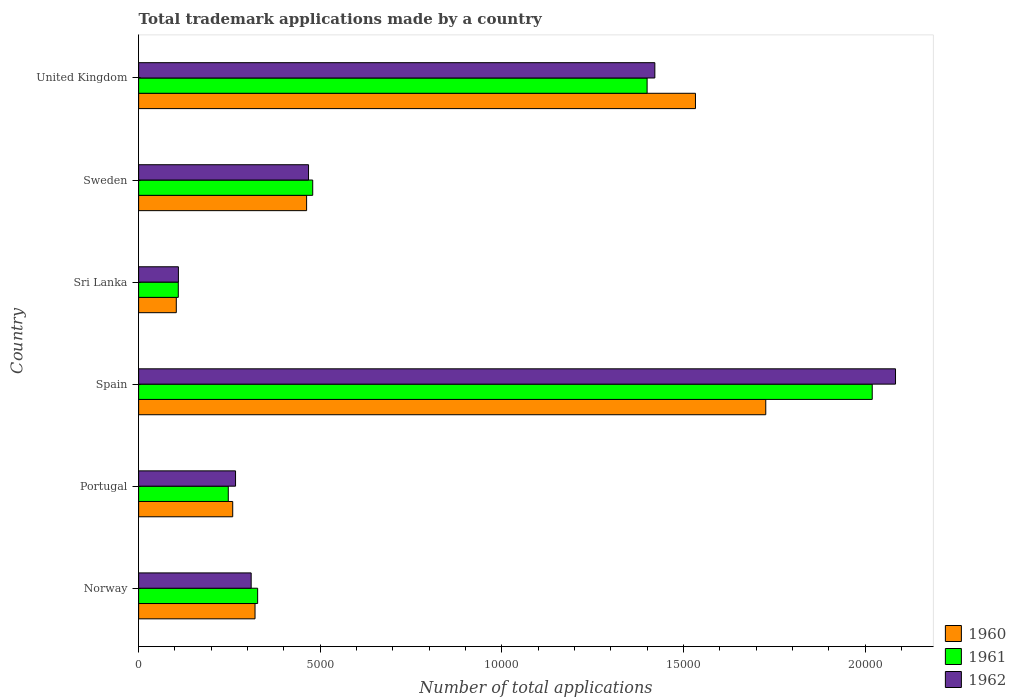How many different coloured bars are there?
Provide a short and direct response. 3. How many groups of bars are there?
Provide a succinct answer. 6. Are the number of bars per tick equal to the number of legend labels?
Your answer should be compact. Yes. How many bars are there on the 4th tick from the bottom?
Your answer should be compact. 3. What is the number of applications made by in 1961 in Sweden?
Your answer should be compact. 4792. Across all countries, what is the maximum number of applications made by in 1962?
Provide a succinct answer. 2.08e+04. Across all countries, what is the minimum number of applications made by in 1961?
Your answer should be very brief. 1092. In which country was the number of applications made by in 1961 minimum?
Your answer should be compact. Sri Lanka. What is the total number of applications made by in 1961 in the graph?
Make the answer very short. 4.58e+04. What is the difference between the number of applications made by in 1962 in Sweden and that in United Kingdom?
Provide a succinct answer. -9533. What is the difference between the number of applications made by in 1961 in United Kingdom and the number of applications made by in 1960 in Portugal?
Offer a terse response. 1.14e+04. What is the average number of applications made by in 1962 per country?
Make the answer very short. 7763.83. What is the difference between the number of applications made by in 1961 and number of applications made by in 1962 in Sri Lanka?
Your answer should be very brief. -3. What is the ratio of the number of applications made by in 1962 in Portugal to that in Sweden?
Your answer should be very brief. 0.57. Is the number of applications made by in 1961 in Norway less than that in Spain?
Ensure brevity in your answer.  Yes. Is the difference between the number of applications made by in 1961 in Portugal and United Kingdom greater than the difference between the number of applications made by in 1962 in Portugal and United Kingdom?
Provide a succinct answer. Yes. What is the difference between the highest and the second highest number of applications made by in 1960?
Give a very brief answer. 1935. What is the difference between the highest and the lowest number of applications made by in 1962?
Provide a short and direct response. 1.97e+04. In how many countries, is the number of applications made by in 1961 greater than the average number of applications made by in 1961 taken over all countries?
Ensure brevity in your answer.  2. Is the sum of the number of applications made by in 1960 in Portugal and Sri Lanka greater than the maximum number of applications made by in 1962 across all countries?
Offer a terse response. No. Is it the case that in every country, the sum of the number of applications made by in 1961 and number of applications made by in 1960 is greater than the number of applications made by in 1962?
Offer a terse response. Yes. Are all the bars in the graph horizontal?
Offer a terse response. Yes. Are the values on the major ticks of X-axis written in scientific E-notation?
Provide a succinct answer. No. Does the graph contain any zero values?
Provide a short and direct response. No. Does the graph contain grids?
Your response must be concise. No. How many legend labels are there?
Ensure brevity in your answer.  3. How are the legend labels stacked?
Ensure brevity in your answer.  Vertical. What is the title of the graph?
Keep it short and to the point. Total trademark applications made by a country. Does "1988" appear as one of the legend labels in the graph?
Provide a short and direct response. No. What is the label or title of the X-axis?
Provide a short and direct response. Number of total applications. What is the label or title of the Y-axis?
Provide a succinct answer. Country. What is the Number of total applications in 1960 in Norway?
Give a very brief answer. 3204. What is the Number of total applications of 1961 in Norway?
Your answer should be very brief. 3276. What is the Number of total applications in 1962 in Norway?
Your response must be concise. 3098. What is the Number of total applications in 1960 in Portugal?
Make the answer very short. 2590. What is the Number of total applications of 1961 in Portugal?
Offer a terse response. 2468. What is the Number of total applications in 1962 in Portugal?
Your response must be concise. 2668. What is the Number of total applications in 1960 in Spain?
Provide a short and direct response. 1.73e+04. What is the Number of total applications in 1961 in Spain?
Provide a short and direct response. 2.02e+04. What is the Number of total applications of 1962 in Spain?
Give a very brief answer. 2.08e+04. What is the Number of total applications of 1960 in Sri Lanka?
Keep it short and to the point. 1037. What is the Number of total applications in 1961 in Sri Lanka?
Offer a terse response. 1092. What is the Number of total applications of 1962 in Sri Lanka?
Your response must be concise. 1095. What is the Number of total applications of 1960 in Sweden?
Your response must be concise. 4624. What is the Number of total applications in 1961 in Sweden?
Offer a very short reply. 4792. What is the Number of total applications in 1962 in Sweden?
Your response must be concise. 4677. What is the Number of total applications in 1960 in United Kingdom?
Ensure brevity in your answer.  1.53e+04. What is the Number of total applications of 1961 in United Kingdom?
Provide a succinct answer. 1.40e+04. What is the Number of total applications of 1962 in United Kingdom?
Offer a very short reply. 1.42e+04. Across all countries, what is the maximum Number of total applications of 1960?
Keep it short and to the point. 1.73e+04. Across all countries, what is the maximum Number of total applications in 1961?
Make the answer very short. 2.02e+04. Across all countries, what is the maximum Number of total applications of 1962?
Give a very brief answer. 2.08e+04. Across all countries, what is the minimum Number of total applications of 1960?
Your answer should be very brief. 1037. Across all countries, what is the minimum Number of total applications in 1961?
Give a very brief answer. 1092. Across all countries, what is the minimum Number of total applications in 1962?
Your response must be concise. 1095. What is the total Number of total applications in 1960 in the graph?
Give a very brief answer. 4.40e+04. What is the total Number of total applications of 1961 in the graph?
Provide a short and direct response. 4.58e+04. What is the total Number of total applications of 1962 in the graph?
Make the answer very short. 4.66e+04. What is the difference between the Number of total applications in 1960 in Norway and that in Portugal?
Keep it short and to the point. 614. What is the difference between the Number of total applications of 1961 in Norway and that in Portugal?
Offer a terse response. 808. What is the difference between the Number of total applications in 1962 in Norway and that in Portugal?
Your answer should be compact. 430. What is the difference between the Number of total applications in 1960 in Norway and that in Spain?
Make the answer very short. -1.41e+04. What is the difference between the Number of total applications in 1961 in Norway and that in Spain?
Make the answer very short. -1.69e+04. What is the difference between the Number of total applications in 1962 in Norway and that in Spain?
Your answer should be compact. -1.77e+04. What is the difference between the Number of total applications of 1960 in Norway and that in Sri Lanka?
Ensure brevity in your answer.  2167. What is the difference between the Number of total applications of 1961 in Norway and that in Sri Lanka?
Offer a terse response. 2184. What is the difference between the Number of total applications of 1962 in Norway and that in Sri Lanka?
Offer a very short reply. 2003. What is the difference between the Number of total applications of 1960 in Norway and that in Sweden?
Provide a short and direct response. -1420. What is the difference between the Number of total applications in 1961 in Norway and that in Sweden?
Keep it short and to the point. -1516. What is the difference between the Number of total applications of 1962 in Norway and that in Sweden?
Give a very brief answer. -1579. What is the difference between the Number of total applications in 1960 in Norway and that in United Kingdom?
Offer a very short reply. -1.21e+04. What is the difference between the Number of total applications of 1961 in Norway and that in United Kingdom?
Give a very brief answer. -1.07e+04. What is the difference between the Number of total applications in 1962 in Norway and that in United Kingdom?
Your answer should be compact. -1.11e+04. What is the difference between the Number of total applications in 1960 in Portugal and that in Spain?
Keep it short and to the point. -1.47e+04. What is the difference between the Number of total applications of 1961 in Portugal and that in Spain?
Provide a short and direct response. -1.77e+04. What is the difference between the Number of total applications in 1962 in Portugal and that in Spain?
Make the answer very short. -1.82e+04. What is the difference between the Number of total applications of 1960 in Portugal and that in Sri Lanka?
Offer a very short reply. 1553. What is the difference between the Number of total applications of 1961 in Portugal and that in Sri Lanka?
Offer a terse response. 1376. What is the difference between the Number of total applications of 1962 in Portugal and that in Sri Lanka?
Give a very brief answer. 1573. What is the difference between the Number of total applications in 1960 in Portugal and that in Sweden?
Your answer should be compact. -2034. What is the difference between the Number of total applications in 1961 in Portugal and that in Sweden?
Make the answer very short. -2324. What is the difference between the Number of total applications in 1962 in Portugal and that in Sweden?
Your answer should be very brief. -2009. What is the difference between the Number of total applications of 1960 in Portugal and that in United Kingdom?
Your response must be concise. -1.27e+04. What is the difference between the Number of total applications of 1961 in Portugal and that in United Kingdom?
Your answer should be compact. -1.15e+04. What is the difference between the Number of total applications of 1962 in Portugal and that in United Kingdom?
Make the answer very short. -1.15e+04. What is the difference between the Number of total applications of 1960 in Spain and that in Sri Lanka?
Provide a short and direct response. 1.62e+04. What is the difference between the Number of total applications in 1961 in Spain and that in Sri Lanka?
Your response must be concise. 1.91e+04. What is the difference between the Number of total applications in 1962 in Spain and that in Sri Lanka?
Offer a terse response. 1.97e+04. What is the difference between the Number of total applications of 1960 in Spain and that in Sweden?
Provide a succinct answer. 1.26e+04. What is the difference between the Number of total applications in 1961 in Spain and that in Sweden?
Keep it short and to the point. 1.54e+04. What is the difference between the Number of total applications in 1962 in Spain and that in Sweden?
Your response must be concise. 1.62e+04. What is the difference between the Number of total applications in 1960 in Spain and that in United Kingdom?
Make the answer very short. 1935. What is the difference between the Number of total applications of 1961 in Spain and that in United Kingdom?
Keep it short and to the point. 6197. What is the difference between the Number of total applications of 1962 in Spain and that in United Kingdom?
Offer a very short reply. 6625. What is the difference between the Number of total applications of 1960 in Sri Lanka and that in Sweden?
Ensure brevity in your answer.  -3587. What is the difference between the Number of total applications in 1961 in Sri Lanka and that in Sweden?
Offer a very short reply. -3700. What is the difference between the Number of total applications in 1962 in Sri Lanka and that in Sweden?
Provide a succinct answer. -3582. What is the difference between the Number of total applications in 1960 in Sri Lanka and that in United Kingdom?
Make the answer very short. -1.43e+04. What is the difference between the Number of total applications in 1961 in Sri Lanka and that in United Kingdom?
Keep it short and to the point. -1.29e+04. What is the difference between the Number of total applications in 1962 in Sri Lanka and that in United Kingdom?
Ensure brevity in your answer.  -1.31e+04. What is the difference between the Number of total applications in 1960 in Sweden and that in United Kingdom?
Provide a succinct answer. -1.07e+04. What is the difference between the Number of total applications of 1961 in Sweden and that in United Kingdom?
Ensure brevity in your answer.  -9205. What is the difference between the Number of total applications in 1962 in Sweden and that in United Kingdom?
Keep it short and to the point. -9533. What is the difference between the Number of total applications of 1960 in Norway and the Number of total applications of 1961 in Portugal?
Give a very brief answer. 736. What is the difference between the Number of total applications in 1960 in Norway and the Number of total applications in 1962 in Portugal?
Provide a succinct answer. 536. What is the difference between the Number of total applications in 1961 in Norway and the Number of total applications in 1962 in Portugal?
Keep it short and to the point. 608. What is the difference between the Number of total applications in 1960 in Norway and the Number of total applications in 1961 in Spain?
Ensure brevity in your answer.  -1.70e+04. What is the difference between the Number of total applications in 1960 in Norway and the Number of total applications in 1962 in Spain?
Give a very brief answer. -1.76e+04. What is the difference between the Number of total applications in 1961 in Norway and the Number of total applications in 1962 in Spain?
Offer a very short reply. -1.76e+04. What is the difference between the Number of total applications of 1960 in Norway and the Number of total applications of 1961 in Sri Lanka?
Provide a short and direct response. 2112. What is the difference between the Number of total applications in 1960 in Norway and the Number of total applications in 1962 in Sri Lanka?
Give a very brief answer. 2109. What is the difference between the Number of total applications in 1961 in Norway and the Number of total applications in 1962 in Sri Lanka?
Make the answer very short. 2181. What is the difference between the Number of total applications in 1960 in Norway and the Number of total applications in 1961 in Sweden?
Your answer should be very brief. -1588. What is the difference between the Number of total applications of 1960 in Norway and the Number of total applications of 1962 in Sweden?
Keep it short and to the point. -1473. What is the difference between the Number of total applications of 1961 in Norway and the Number of total applications of 1962 in Sweden?
Make the answer very short. -1401. What is the difference between the Number of total applications in 1960 in Norway and the Number of total applications in 1961 in United Kingdom?
Your answer should be compact. -1.08e+04. What is the difference between the Number of total applications in 1960 in Norway and the Number of total applications in 1962 in United Kingdom?
Ensure brevity in your answer.  -1.10e+04. What is the difference between the Number of total applications of 1961 in Norway and the Number of total applications of 1962 in United Kingdom?
Provide a succinct answer. -1.09e+04. What is the difference between the Number of total applications in 1960 in Portugal and the Number of total applications in 1961 in Spain?
Your response must be concise. -1.76e+04. What is the difference between the Number of total applications of 1960 in Portugal and the Number of total applications of 1962 in Spain?
Your answer should be compact. -1.82e+04. What is the difference between the Number of total applications in 1961 in Portugal and the Number of total applications in 1962 in Spain?
Provide a short and direct response. -1.84e+04. What is the difference between the Number of total applications of 1960 in Portugal and the Number of total applications of 1961 in Sri Lanka?
Your answer should be compact. 1498. What is the difference between the Number of total applications of 1960 in Portugal and the Number of total applications of 1962 in Sri Lanka?
Provide a short and direct response. 1495. What is the difference between the Number of total applications of 1961 in Portugal and the Number of total applications of 1962 in Sri Lanka?
Keep it short and to the point. 1373. What is the difference between the Number of total applications in 1960 in Portugal and the Number of total applications in 1961 in Sweden?
Your response must be concise. -2202. What is the difference between the Number of total applications of 1960 in Portugal and the Number of total applications of 1962 in Sweden?
Give a very brief answer. -2087. What is the difference between the Number of total applications in 1961 in Portugal and the Number of total applications in 1962 in Sweden?
Keep it short and to the point. -2209. What is the difference between the Number of total applications in 1960 in Portugal and the Number of total applications in 1961 in United Kingdom?
Provide a succinct answer. -1.14e+04. What is the difference between the Number of total applications of 1960 in Portugal and the Number of total applications of 1962 in United Kingdom?
Provide a succinct answer. -1.16e+04. What is the difference between the Number of total applications in 1961 in Portugal and the Number of total applications in 1962 in United Kingdom?
Ensure brevity in your answer.  -1.17e+04. What is the difference between the Number of total applications of 1960 in Spain and the Number of total applications of 1961 in Sri Lanka?
Give a very brief answer. 1.62e+04. What is the difference between the Number of total applications of 1960 in Spain and the Number of total applications of 1962 in Sri Lanka?
Give a very brief answer. 1.62e+04. What is the difference between the Number of total applications of 1961 in Spain and the Number of total applications of 1962 in Sri Lanka?
Ensure brevity in your answer.  1.91e+04. What is the difference between the Number of total applications in 1960 in Spain and the Number of total applications in 1961 in Sweden?
Give a very brief answer. 1.25e+04. What is the difference between the Number of total applications of 1960 in Spain and the Number of total applications of 1962 in Sweden?
Your answer should be compact. 1.26e+04. What is the difference between the Number of total applications of 1961 in Spain and the Number of total applications of 1962 in Sweden?
Your answer should be very brief. 1.55e+04. What is the difference between the Number of total applications in 1960 in Spain and the Number of total applications in 1961 in United Kingdom?
Your answer should be very brief. 3266. What is the difference between the Number of total applications of 1960 in Spain and the Number of total applications of 1962 in United Kingdom?
Ensure brevity in your answer.  3053. What is the difference between the Number of total applications in 1961 in Spain and the Number of total applications in 1962 in United Kingdom?
Your answer should be compact. 5984. What is the difference between the Number of total applications in 1960 in Sri Lanka and the Number of total applications in 1961 in Sweden?
Make the answer very short. -3755. What is the difference between the Number of total applications in 1960 in Sri Lanka and the Number of total applications in 1962 in Sweden?
Your answer should be compact. -3640. What is the difference between the Number of total applications of 1961 in Sri Lanka and the Number of total applications of 1962 in Sweden?
Make the answer very short. -3585. What is the difference between the Number of total applications of 1960 in Sri Lanka and the Number of total applications of 1961 in United Kingdom?
Keep it short and to the point. -1.30e+04. What is the difference between the Number of total applications of 1960 in Sri Lanka and the Number of total applications of 1962 in United Kingdom?
Offer a terse response. -1.32e+04. What is the difference between the Number of total applications in 1961 in Sri Lanka and the Number of total applications in 1962 in United Kingdom?
Your response must be concise. -1.31e+04. What is the difference between the Number of total applications in 1960 in Sweden and the Number of total applications in 1961 in United Kingdom?
Give a very brief answer. -9373. What is the difference between the Number of total applications in 1960 in Sweden and the Number of total applications in 1962 in United Kingdom?
Your response must be concise. -9586. What is the difference between the Number of total applications of 1961 in Sweden and the Number of total applications of 1962 in United Kingdom?
Offer a terse response. -9418. What is the average Number of total applications of 1960 per country?
Keep it short and to the point. 7341. What is the average Number of total applications of 1961 per country?
Make the answer very short. 7636.5. What is the average Number of total applications of 1962 per country?
Make the answer very short. 7763.83. What is the difference between the Number of total applications of 1960 and Number of total applications of 1961 in Norway?
Provide a short and direct response. -72. What is the difference between the Number of total applications in 1960 and Number of total applications in 1962 in Norway?
Give a very brief answer. 106. What is the difference between the Number of total applications in 1961 and Number of total applications in 1962 in Norway?
Provide a succinct answer. 178. What is the difference between the Number of total applications of 1960 and Number of total applications of 1961 in Portugal?
Your response must be concise. 122. What is the difference between the Number of total applications in 1960 and Number of total applications in 1962 in Portugal?
Your response must be concise. -78. What is the difference between the Number of total applications of 1961 and Number of total applications of 1962 in Portugal?
Offer a very short reply. -200. What is the difference between the Number of total applications of 1960 and Number of total applications of 1961 in Spain?
Make the answer very short. -2931. What is the difference between the Number of total applications in 1960 and Number of total applications in 1962 in Spain?
Your response must be concise. -3572. What is the difference between the Number of total applications in 1961 and Number of total applications in 1962 in Spain?
Provide a succinct answer. -641. What is the difference between the Number of total applications in 1960 and Number of total applications in 1961 in Sri Lanka?
Give a very brief answer. -55. What is the difference between the Number of total applications in 1960 and Number of total applications in 1962 in Sri Lanka?
Give a very brief answer. -58. What is the difference between the Number of total applications of 1960 and Number of total applications of 1961 in Sweden?
Offer a terse response. -168. What is the difference between the Number of total applications in 1960 and Number of total applications in 1962 in Sweden?
Offer a terse response. -53. What is the difference between the Number of total applications of 1961 and Number of total applications of 1962 in Sweden?
Keep it short and to the point. 115. What is the difference between the Number of total applications of 1960 and Number of total applications of 1961 in United Kingdom?
Give a very brief answer. 1331. What is the difference between the Number of total applications of 1960 and Number of total applications of 1962 in United Kingdom?
Your response must be concise. 1118. What is the difference between the Number of total applications of 1961 and Number of total applications of 1962 in United Kingdom?
Your response must be concise. -213. What is the ratio of the Number of total applications in 1960 in Norway to that in Portugal?
Your response must be concise. 1.24. What is the ratio of the Number of total applications in 1961 in Norway to that in Portugal?
Offer a very short reply. 1.33. What is the ratio of the Number of total applications in 1962 in Norway to that in Portugal?
Offer a terse response. 1.16. What is the ratio of the Number of total applications in 1960 in Norway to that in Spain?
Give a very brief answer. 0.19. What is the ratio of the Number of total applications of 1961 in Norway to that in Spain?
Provide a short and direct response. 0.16. What is the ratio of the Number of total applications in 1962 in Norway to that in Spain?
Provide a short and direct response. 0.15. What is the ratio of the Number of total applications in 1960 in Norway to that in Sri Lanka?
Make the answer very short. 3.09. What is the ratio of the Number of total applications of 1962 in Norway to that in Sri Lanka?
Keep it short and to the point. 2.83. What is the ratio of the Number of total applications of 1960 in Norway to that in Sweden?
Offer a terse response. 0.69. What is the ratio of the Number of total applications of 1961 in Norway to that in Sweden?
Give a very brief answer. 0.68. What is the ratio of the Number of total applications in 1962 in Norway to that in Sweden?
Give a very brief answer. 0.66. What is the ratio of the Number of total applications in 1960 in Norway to that in United Kingdom?
Keep it short and to the point. 0.21. What is the ratio of the Number of total applications in 1961 in Norway to that in United Kingdom?
Provide a succinct answer. 0.23. What is the ratio of the Number of total applications of 1962 in Norway to that in United Kingdom?
Make the answer very short. 0.22. What is the ratio of the Number of total applications of 1960 in Portugal to that in Spain?
Offer a very short reply. 0.15. What is the ratio of the Number of total applications of 1961 in Portugal to that in Spain?
Provide a short and direct response. 0.12. What is the ratio of the Number of total applications of 1962 in Portugal to that in Spain?
Give a very brief answer. 0.13. What is the ratio of the Number of total applications of 1960 in Portugal to that in Sri Lanka?
Provide a short and direct response. 2.5. What is the ratio of the Number of total applications in 1961 in Portugal to that in Sri Lanka?
Make the answer very short. 2.26. What is the ratio of the Number of total applications of 1962 in Portugal to that in Sri Lanka?
Make the answer very short. 2.44. What is the ratio of the Number of total applications in 1960 in Portugal to that in Sweden?
Provide a succinct answer. 0.56. What is the ratio of the Number of total applications in 1961 in Portugal to that in Sweden?
Your response must be concise. 0.52. What is the ratio of the Number of total applications in 1962 in Portugal to that in Sweden?
Make the answer very short. 0.57. What is the ratio of the Number of total applications in 1960 in Portugal to that in United Kingdom?
Offer a very short reply. 0.17. What is the ratio of the Number of total applications of 1961 in Portugal to that in United Kingdom?
Make the answer very short. 0.18. What is the ratio of the Number of total applications of 1962 in Portugal to that in United Kingdom?
Your response must be concise. 0.19. What is the ratio of the Number of total applications in 1960 in Spain to that in Sri Lanka?
Ensure brevity in your answer.  16.65. What is the ratio of the Number of total applications in 1961 in Spain to that in Sri Lanka?
Make the answer very short. 18.49. What is the ratio of the Number of total applications in 1962 in Spain to that in Sri Lanka?
Your response must be concise. 19.03. What is the ratio of the Number of total applications in 1960 in Spain to that in Sweden?
Make the answer very short. 3.73. What is the ratio of the Number of total applications in 1961 in Spain to that in Sweden?
Keep it short and to the point. 4.21. What is the ratio of the Number of total applications of 1962 in Spain to that in Sweden?
Provide a short and direct response. 4.45. What is the ratio of the Number of total applications in 1960 in Spain to that in United Kingdom?
Your answer should be very brief. 1.13. What is the ratio of the Number of total applications of 1961 in Spain to that in United Kingdom?
Give a very brief answer. 1.44. What is the ratio of the Number of total applications in 1962 in Spain to that in United Kingdom?
Make the answer very short. 1.47. What is the ratio of the Number of total applications of 1960 in Sri Lanka to that in Sweden?
Give a very brief answer. 0.22. What is the ratio of the Number of total applications in 1961 in Sri Lanka to that in Sweden?
Your response must be concise. 0.23. What is the ratio of the Number of total applications in 1962 in Sri Lanka to that in Sweden?
Your answer should be very brief. 0.23. What is the ratio of the Number of total applications of 1960 in Sri Lanka to that in United Kingdom?
Your response must be concise. 0.07. What is the ratio of the Number of total applications of 1961 in Sri Lanka to that in United Kingdom?
Your answer should be compact. 0.08. What is the ratio of the Number of total applications of 1962 in Sri Lanka to that in United Kingdom?
Offer a terse response. 0.08. What is the ratio of the Number of total applications in 1960 in Sweden to that in United Kingdom?
Give a very brief answer. 0.3. What is the ratio of the Number of total applications of 1961 in Sweden to that in United Kingdom?
Your answer should be very brief. 0.34. What is the ratio of the Number of total applications of 1962 in Sweden to that in United Kingdom?
Provide a short and direct response. 0.33. What is the difference between the highest and the second highest Number of total applications in 1960?
Your response must be concise. 1935. What is the difference between the highest and the second highest Number of total applications of 1961?
Make the answer very short. 6197. What is the difference between the highest and the second highest Number of total applications of 1962?
Make the answer very short. 6625. What is the difference between the highest and the lowest Number of total applications of 1960?
Provide a short and direct response. 1.62e+04. What is the difference between the highest and the lowest Number of total applications of 1961?
Ensure brevity in your answer.  1.91e+04. What is the difference between the highest and the lowest Number of total applications in 1962?
Make the answer very short. 1.97e+04. 